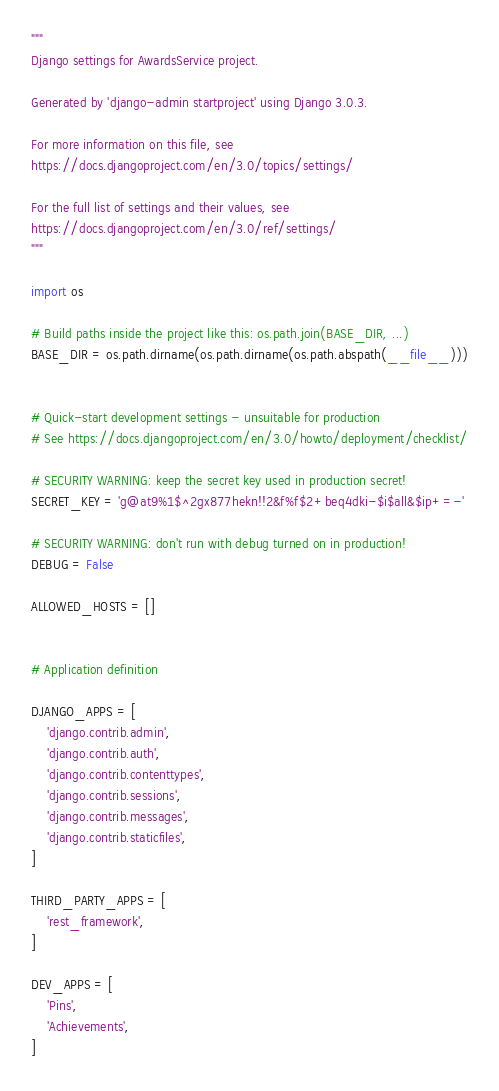Convert code to text. <code><loc_0><loc_0><loc_500><loc_500><_Python_>"""
Django settings for AwardsService project.

Generated by 'django-admin startproject' using Django 3.0.3.

For more information on this file, see
https://docs.djangoproject.com/en/3.0/topics/settings/

For the full list of settings and their values, see
https://docs.djangoproject.com/en/3.0/ref/settings/
"""

import os

# Build paths inside the project like this: os.path.join(BASE_DIR, ...)
BASE_DIR = os.path.dirname(os.path.dirname(os.path.abspath(__file__)))


# Quick-start development settings - unsuitable for production
# See https://docs.djangoproject.com/en/3.0/howto/deployment/checklist/

# SECURITY WARNING: keep the secret key used in production secret!
SECRET_KEY = 'g@at9%1$^2gx877hekn!!2&f%f$2+beq4dki-$i$all&$ip+=-'

# SECURITY WARNING: don't run with debug turned on in production!
DEBUG = False

ALLOWED_HOSTS = []


# Application definition

DJANGO_APPS = [
    'django.contrib.admin',
    'django.contrib.auth',
    'django.contrib.contenttypes',
    'django.contrib.sessions',
    'django.contrib.messages',
    'django.contrib.staticfiles',
]

THIRD_PARTY_APPS = [
    'rest_framework',
]

DEV_APPS = [
    'Pins',
    'Achievements',
]
</code> 